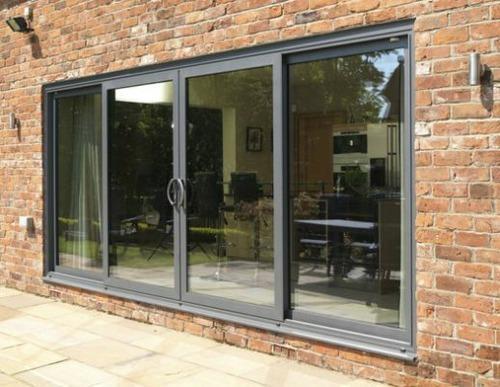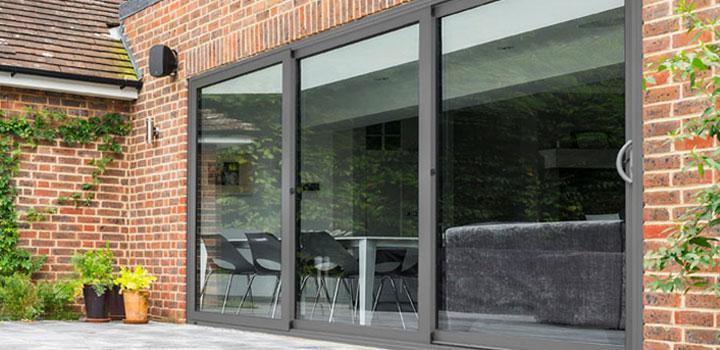The first image is the image on the left, the second image is the image on the right. Examine the images to the left and right. Is the description "An image shows a brick wall with one multi-door sliding glass element that is open in the center, revealing a room of furniture." accurate? Answer yes or no. No. 